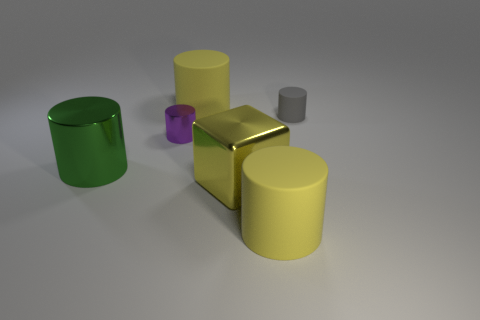Subtract 1 cylinders. How many cylinders are left? 4 Subtract all cyan cylinders. Subtract all green spheres. How many cylinders are left? 5 Add 3 small gray objects. How many objects exist? 9 Subtract all cylinders. How many objects are left? 1 Subtract all green metallic objects. Subtract all tiny purple shiny things. How many objects are left? 4 Add 5 large yellow metallic cubes. How many large yellow metallic cubes are left? 6 Add 5 green cylinders. How many green cylinders exist? 6 Subtract 0 blue cylinders. How many objects are left? 6 